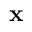Convert formula to latex. <formula><loc_0><loc_0><loc_500><loc_500>\mathbf x</formula> 